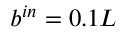<formula> <loc_0><loc_0><loc_500><loc_500>b ^ { i n } = 0 . 1 L</formula> 